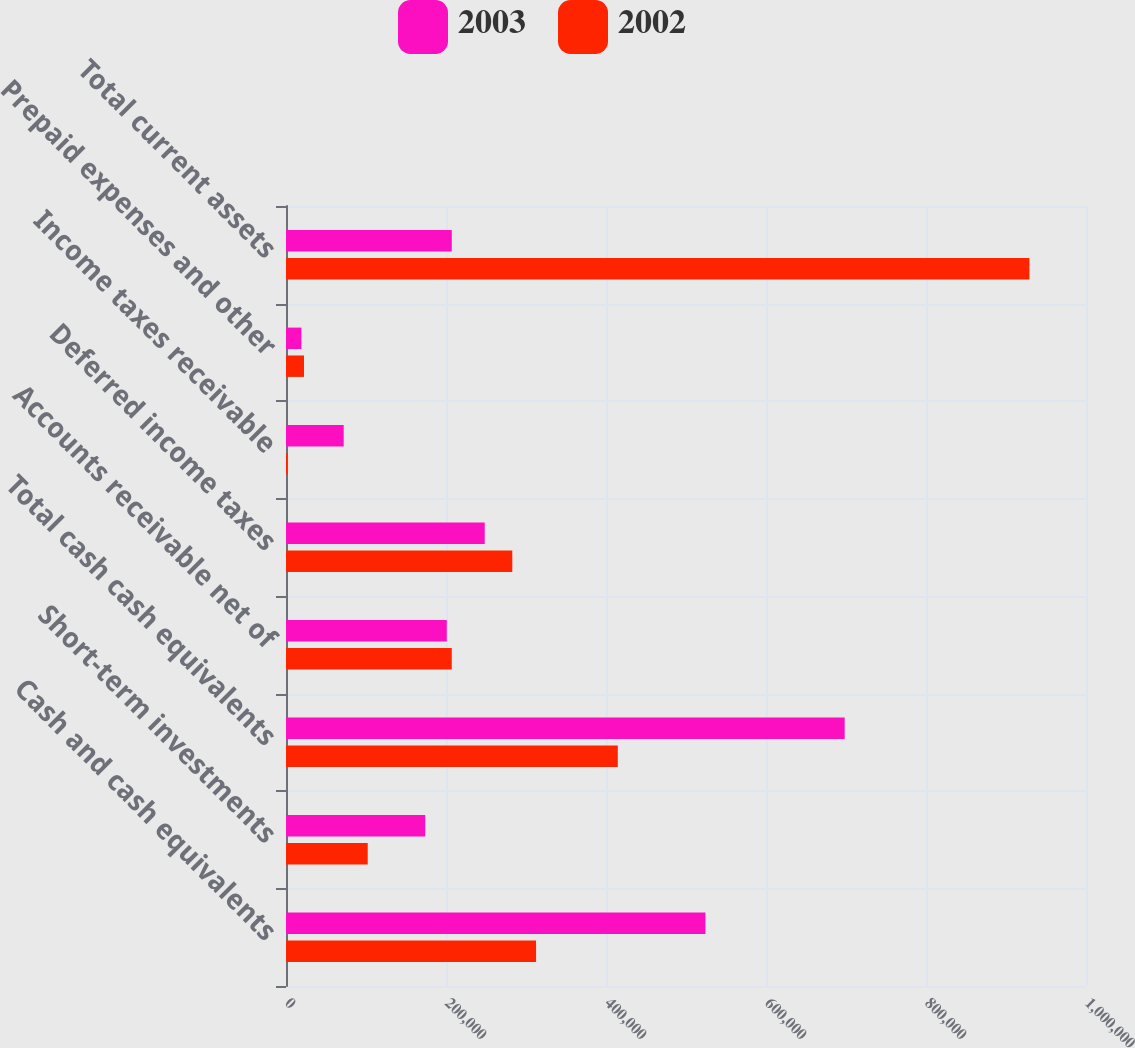<chart> <loc_0><loc_0><loc_500><loc_500><stacked_bar_chart><ecel><fcel>Cash and cash equivalents<fcel>Short-term investments<fcel>Total cash cash equivalents<fcel>Accounts receivable net of<fcel>Deferred income taxes<fcel>Income taxes receivable<fcel>Prepaid expenses and other<fcel>Total current assets<nl><fcel>2003<fcel>524308<fcel>174049<fcel>698357<fcel>200998<fcel>248425<fcel>72124<fcel>19302<fcel>207206<nl><fcel>2002<fcel>312580<fcel>102153<fcel>414733<fcel>207206<fcel>282867<fcel>2038<fcel>22471<fcel>929315<nl></chart> 